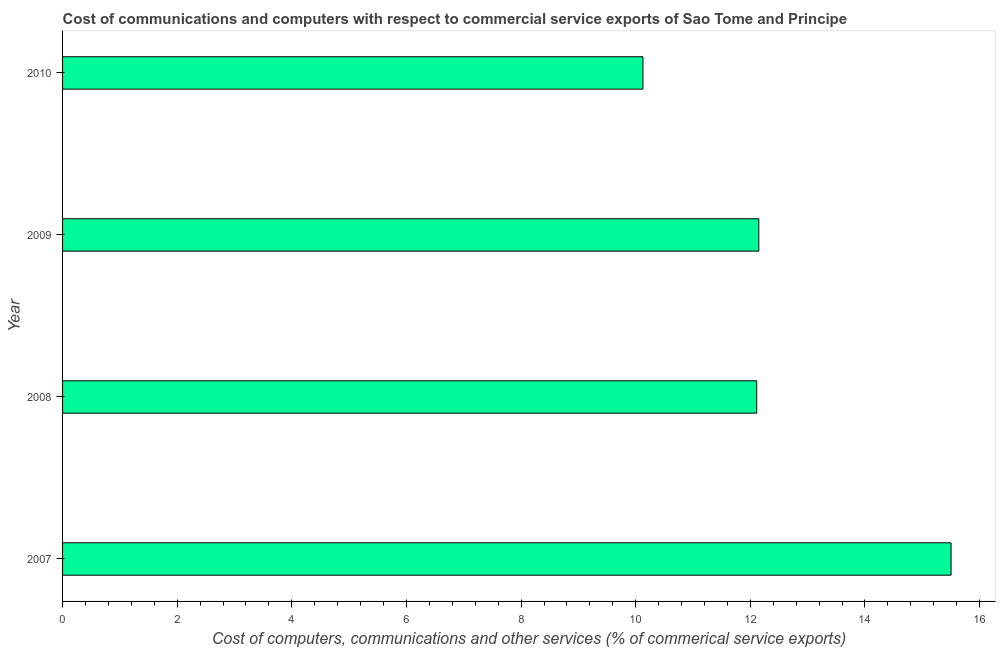What is the title of the graph?
Provide a succinct answer. Cost of communications and computers with respect to commercial service exports of Sao Tome and Principe. What is the label or title of the X-axis?
Ensure brevity in your answer.  Cost of computers, communications and other services (% of commerical service exports). What is the label or title of the Y-axis?
Ensure brevity in your answer.  Year. What is the  computer and other services in 2007?
Give a very brief answer. 15.5. Across all years, what is the maximum cost of communications?
Provide a short and direct response. 15.5. Across all years, what is the minimum cost of communications?
Give a very brief answer. 10.13. In which year was the  computer and other services maximum?
Your response must be concise. 2007. In which year was the cost of communications minimum?
Keep it short and to the point. 2010. What is the sum of the  computer and other services?
Your response must be concise. 49.89. What is the difference between the cost of communications in 2007 and 2010?
Offer a very short reply. 5.38. What is the average cost of communications per year?
Make the answer very short. 12.47. What is the median cost of communications?
Provide a short and direct response. 12.13. What is the ratio of the cost of communications in 2008 to that in 2010?
Provide a succinct answer. 1.2. Is the cost of communications in 2009 less than that in 2010?
Keep it short and to the point. No. Is the difference between the  computer and other services in 2009 and 2010 greater than the difference between any two years?
Offer a very short reply. No. What is the difference between the highest and the second highest  computer and other services?
Offer a very short reply. 3.35. What is the difference between the highest and the lowest  computer and other services?
Keep it short and to the point. 5.38. In how many years, is the cost of communications greater than the average cost of communications taken over all years?
Ensure brevity in your answer.  1. How many bars are there?
Your response must be concise. 4. How many years are there in the graph?
Provide a succinct answer. 4. What is the Cost of computers, communications and other services (% of commerical service exports) in 2007?
Your answer should be compact. 15.5. What is the Cost of computers, communications and other services (% of commerical service exports) in 2008?
Give a very brief answer. 12.11. What is the Cost of computers, communications and other services (% of commerical service exports) in 2009?
Provide a short and direct response. 12.15. What is the Cost of computers, communications and other services (% of commerical service exports) in 2010?
Keep it short and to the point. 10.13. What is the difference between the Cost of computers, communications and other services (% of commerical service exports) in 2007 and 2008?
Your answer should be compact. 3.39. What is the difference between the Cost of computers, communications and other services (% of commerical service exports) in 2007 and 2009?
Provide a succinct answer. 3.35. What is the difference between the Cost of computers, communications and other services (% of commerical service exports) in 2007 and 2010?
Ensure brevity in your answer.  5.38. What is the difference between the Cost of computers, communications and other services (% of commerical service exports) in 2008 and 2009?
Your answer should be compact. -0.04. What is the difference between the Cost of computers, communications and other services (% of commerical service exports) in 2008 and 2010?
Offer a terse response. 1.98. What is the difference between the Cost of computers, communications and other services (% of commerical service exports) in 2009 and 2010?
Your response must be concise. 2.02. What is the ratio of the Cost of computers, communications and other services (% of commerical service exports) in 2007 to that in 2008?
Give a very brief answer. 1.28. What is the ratio of the Cost of computers, communications and other services (% of commerical service exports) in 2007 to that in 2009?
Provide a succinct answer. 1.28. What is the ratio of the Cost of computers, communications and other services (% of commerical service exports) in 2007 to that in 2010?
Your answer should be compact. 1.53. What is the ratio of the Cost of computers, communications and other services (% of commerical service exports) in 2008 to that in 2009?
Offer a very short reply. 1. What is the ratio of the Cost of computers, communications and other services (% of commerical service exports) in 2008 to that in 2010?
Your answer should be compact. 1.2. What is the ratio of the Cost of computers, communications and other services (% of commerical service exports) in 2009 to that in 2010?
Give a very brief answer. 1.2. 